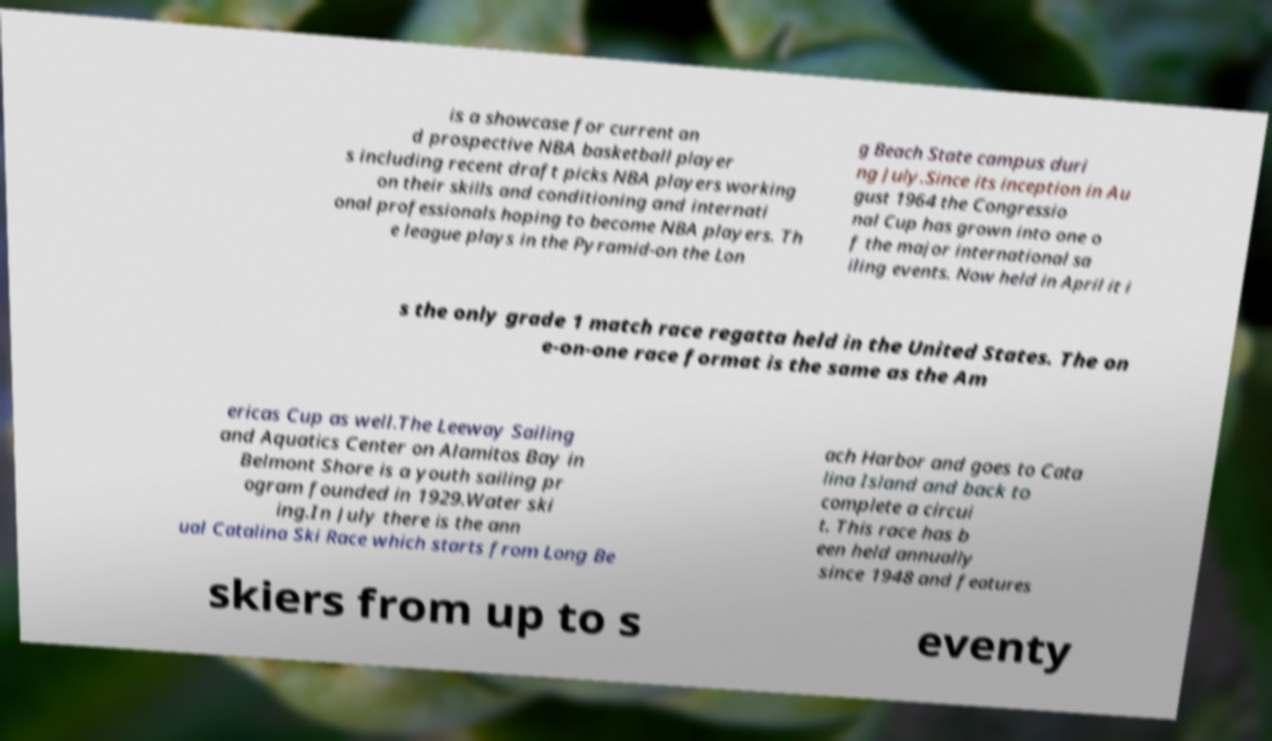Can you read and provide the text displayed in the image?This photo seems to have some interesting text. Can you extract and type it out for me? is a showcase for current an d prospective NBA basketball player s including recent draft picks NBA players working on their skills and conditioning and internati onal professionals hoping to become NBA players. Th e league plays in the Pyramid-on the Lon g Beach State campus duri ng July.Since its inception in Au gust 1964 the Congressio nal Cup has grown into one o f the major international sa iling events. Now held in April it i s the only grade 1 match race regatta held in the United States. The on e-on-one race format is the same as the Am ericas Cup as well.The Leeway Sailing and Aquatics Center on Alamitos Bay in Belmont Shore is a youth sailing pr ogram founded in 1929.Water ski ing.In July there is the ann ual Catalina Ski Race which starts from Long Be ach Harbor and goes to Cata lina Island and back to complete a circui t. This race has b een held annually since 1948 and features skiers from up to s eventy 